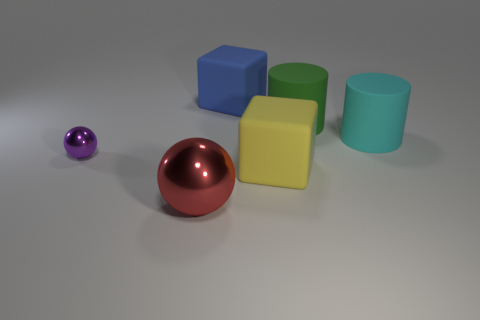Add 1 large purple objects. How many objects exist? 7 Subtract all spheres. How many objects are left? 4 Subtract 0 gray cylinders. How many objects are left? 6 Subtract all cylinders. Subtract all matte things. How many objects are left? 0 Add 3 large red metal things. How many large red metal things are left? 4 Add 4 large objects. How many large objects exist? 9 